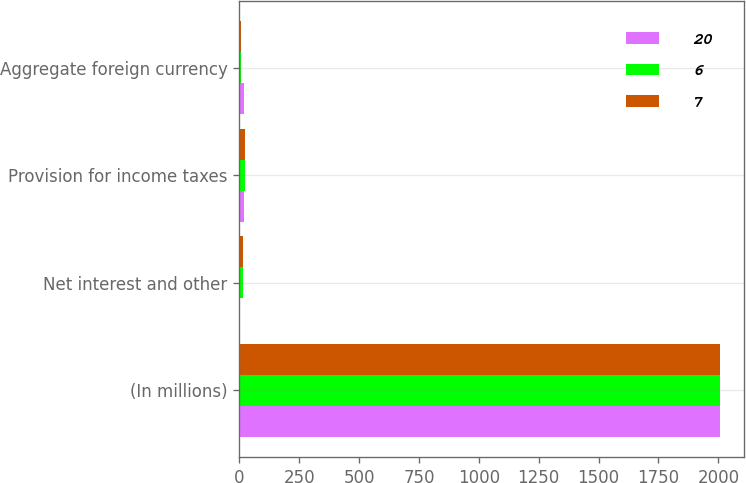Convert chart. <chart><loc_0><loc_0><loc_500><loc_500><stacked_bar_chart><ecel><fcel>(In millions)<fcel>Net interest and other<fcel>Provision for income taxes<fcel>Aggregate foreign currency<nl><fcel>20<fcel>2007<fcel>2<fcel>18<fcel>20<nl><fcel>6<fcel>2006<fcel>16<fcel>22<fcel>6<nl><fcel>7<fcel>2005<fcel>17<fcel>24<fcel>7<nl></chart> 